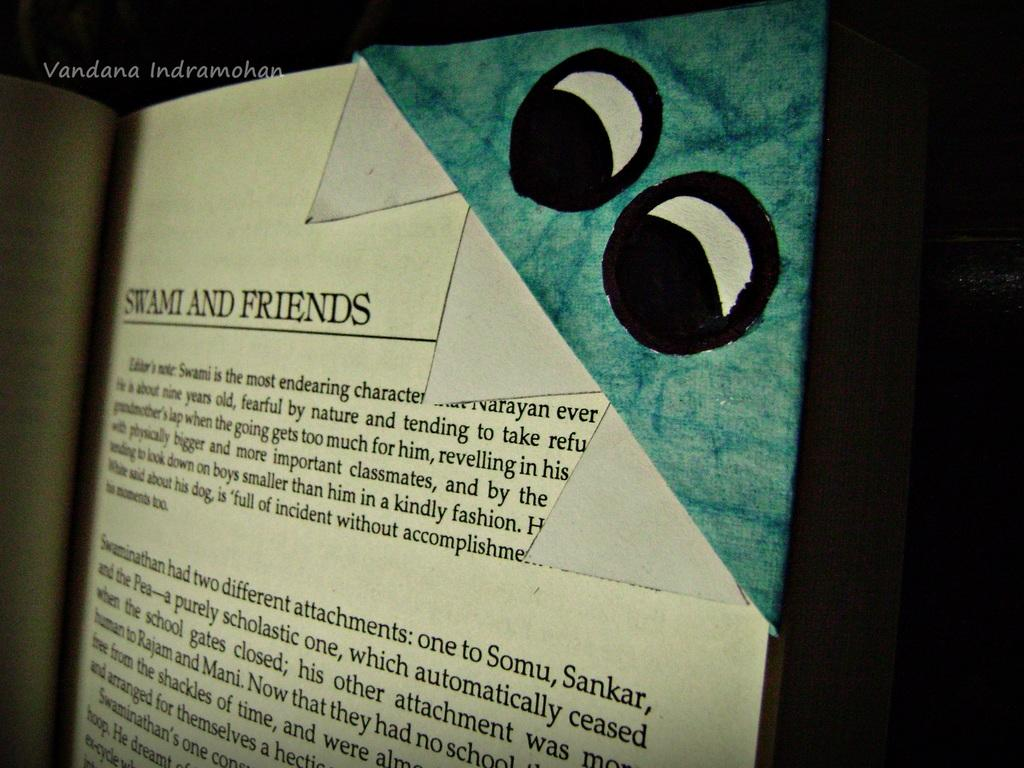<image>
Offer a succinct explanation of the picture presented. the word friends is on the front of a book 